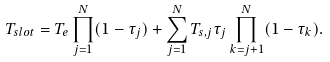Convert formula to latex. <formula><loc_0><loc_0><loc_500><loc_500>T _ { s l o t } = T _ { e } \prod _ { j = 1 } ^ { N } ( 1 - \tau _ { j } ) + \sum _ { j = 1 } ^ { N } T _ { s , j } \tau _ { j } \prod _ { k = j + 1 } ^ { N } ( 1 - \tau _ { k } ) .</formula> 